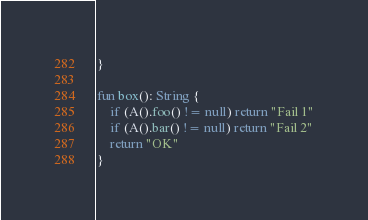<code> <loc_0><loc_0><loc_500><loc_500><_Kotlin_>}

fun box(): String {
    if (A().foo() != null) return "Fail 1"
    if (A().bar() != null) return "Fail 2"
    return "OK"
}
</code> 